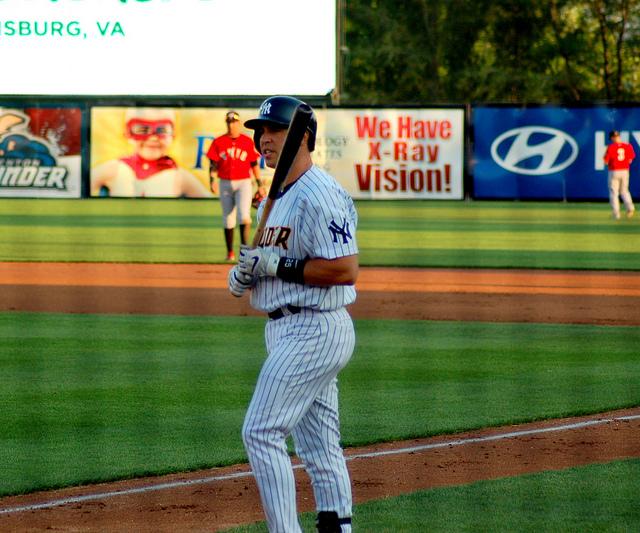What state is the guy closest to the camera playing for?
Short answer required. New york. Where is the man standing?
Quick response, please. Field. Is he tired?
Be succinct. No. What sport is being played?
Write a very short answer. Baseball. Is there only three people in this photo?
Answer briefly. Yes. What do 'we have'?
Quick response, please. X-ray vision. What is the banner promoting?
Short answer required. Hyundai. Are the men playing tennis?
Answer briefly. No. 